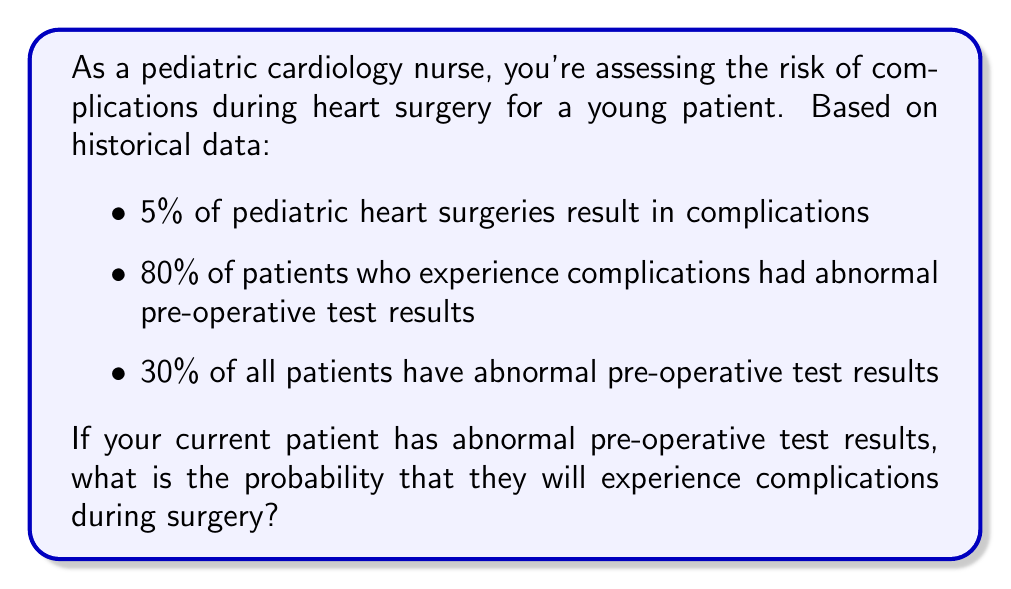Provide a solution to this math problem. To solve this problem, we'll use Bayes' Theorem. Let's define our events:

A: The patient experiences complications
B: The patient has abnormal pre-operative test results

We're given:
P(A) = 0.05 (5% of surgeries result in complications)
P(B|A) = 0.80 (80% of patients with complications had abnormal test results)
P(B) = 0.30 (30% of all patients have abnormal test results)

We want to find P(A|B), the probability of complications given abnormal test results.

Bayes' Theorem states:

$$ P(A|B) = \frac{P(B|A) \cdot P(A)}{P(B)} $$

Substituting our values:

$$ P(A|B) = \frac{0.80 \cdot 0.05}{0.30} $$

$$ P(A|B) = \frac{0.04}{0.30} $$

$$ P(A|B) = \frac{2}{15} \approx 0.1333 $$

Therefore, the probability of complications given abnormal test results is approximately 13.33% or about 1 in 7.5.
Answer: The probability that the patient will experience complications during surgery, given abnormal pre-operative test results, is $\frac{2}{15}$ or approximately 13.33%. 